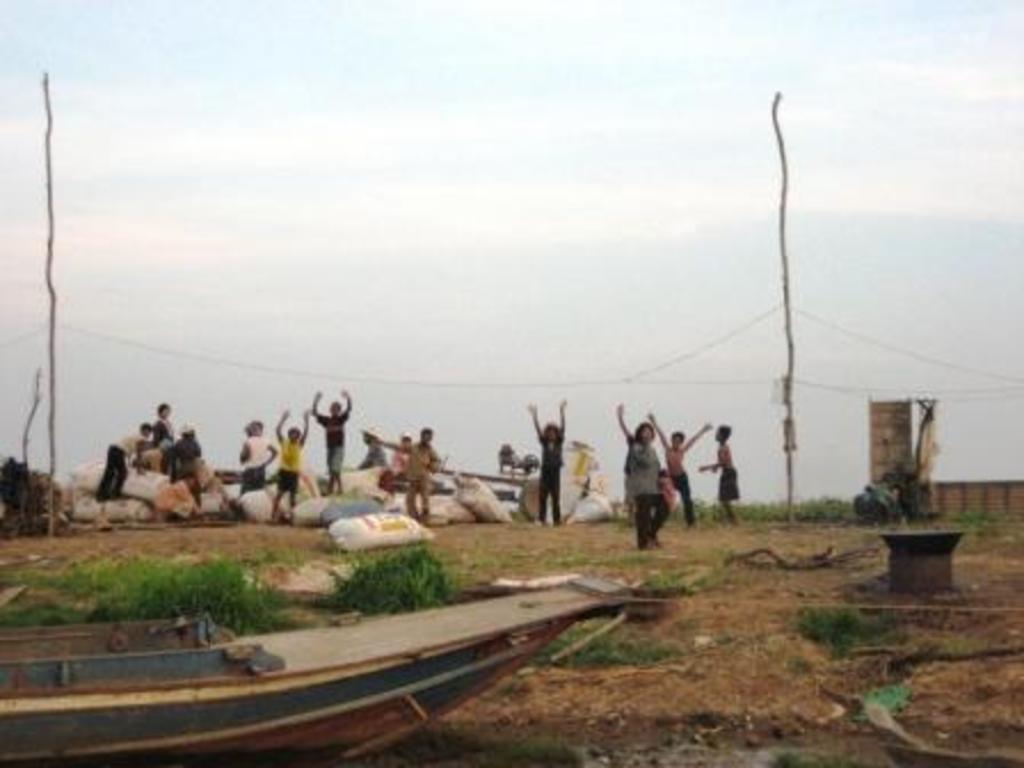How would you summarize this image in a sentence or two? In this image I can see number of people, grass, a boat, few white colour bags, wires, few poles and the sky. 